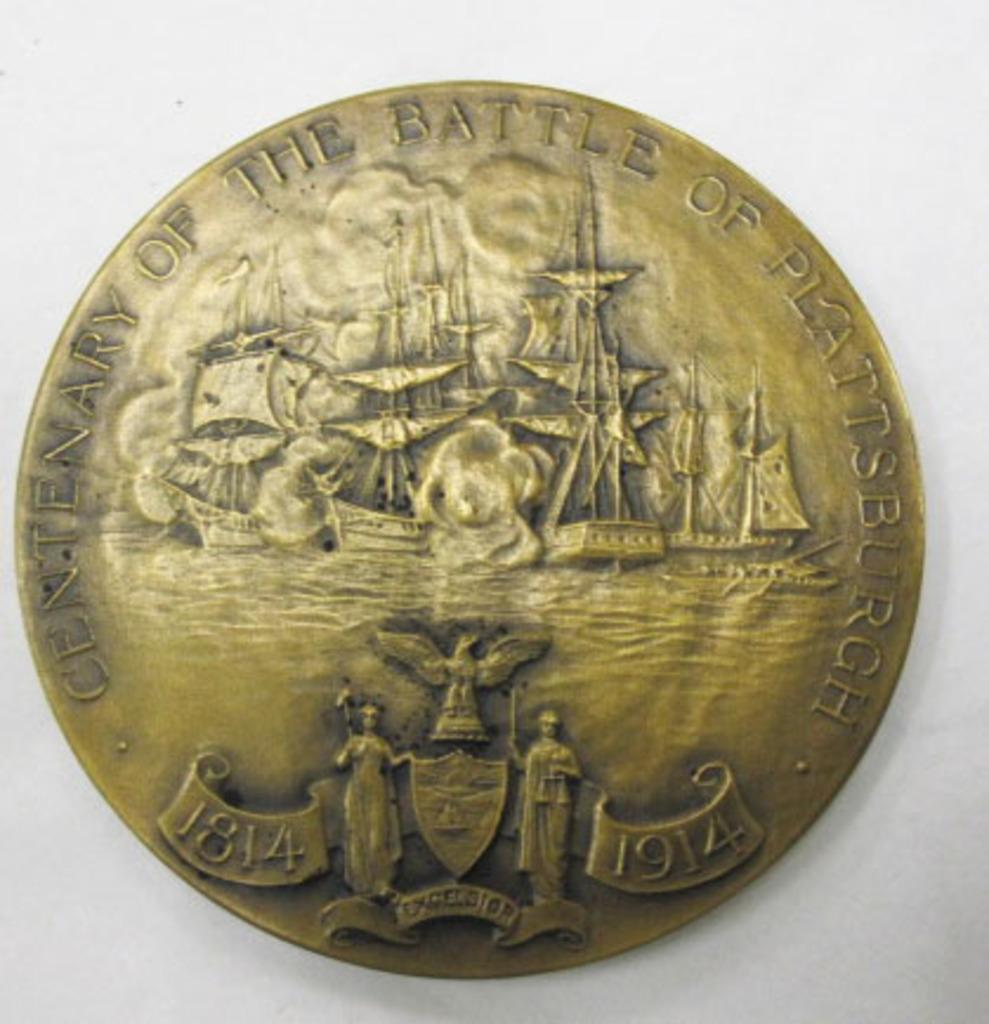<image>
Relay a brief, clear account of the picture shown. A coin with you years 1814 and 1914 on it with ships in the backgroud. 